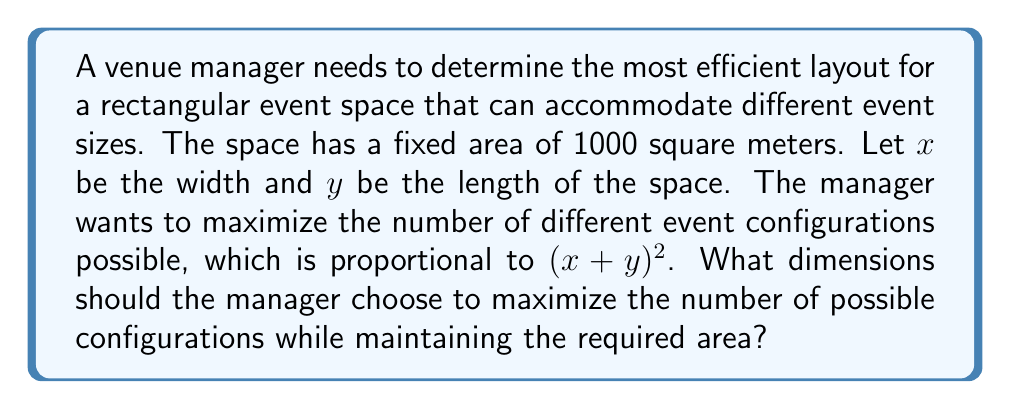Show me your answer to this math problem. Let's approach this step-by-step using calculus and optimization techniques:

1) We know that the area of the rectangle is fixed at 1000 square meters. This gives us our first equation:

   $$ xy = 1000 $$

2) We want to maximize $(x+y)^2$. Let's call this function $f(x,y)$:

   $$ f(x,y) = (x+y)^2 $$

3) We can use the method of Lagrange multipliers to maximize $f(x,y)$ subject to the constraint $xy = 1000$. Let's define the Lagrangian function:

   $$ L(x,y,\lambda) = (x+y)^2 - \lambda(xy - 1000) $$

4) Now, we set the partial derivatives of $L$ with respect to $x$, $y$, and $\lambda$ to zero:

   $$ \frac{\partial L}{\partial x} = 2(x+y) - \lambda y = 0 $$
   $$ \frac{\partial L}{\partial y} = 2(x+y) - \lambda x = 0 $$
   $$ \frac{\partial L}{\partial \lambda} = xy - 1000 = 0 $$

5) From the first two equations, we can see that:

   $$ 2(x+y) = \lambda y $$
   $$ 2(x+y) = \lambda x $$

6) This implies that $\lambda y = \lambda x$, or simply $x = y$.

7) Substituting this into our area constraint:

   $$ x^2 = 1000 $$

8) Solving for $x$ (and $y$):

   $$ x = y = \sqrt{1000} \approx 31.62 $$

Therefore, the most efficient layout is a square with sides of approximately 31.62 meters.
Answer: $x = y = \sqrt{1000} \approx 31.62$ meters 